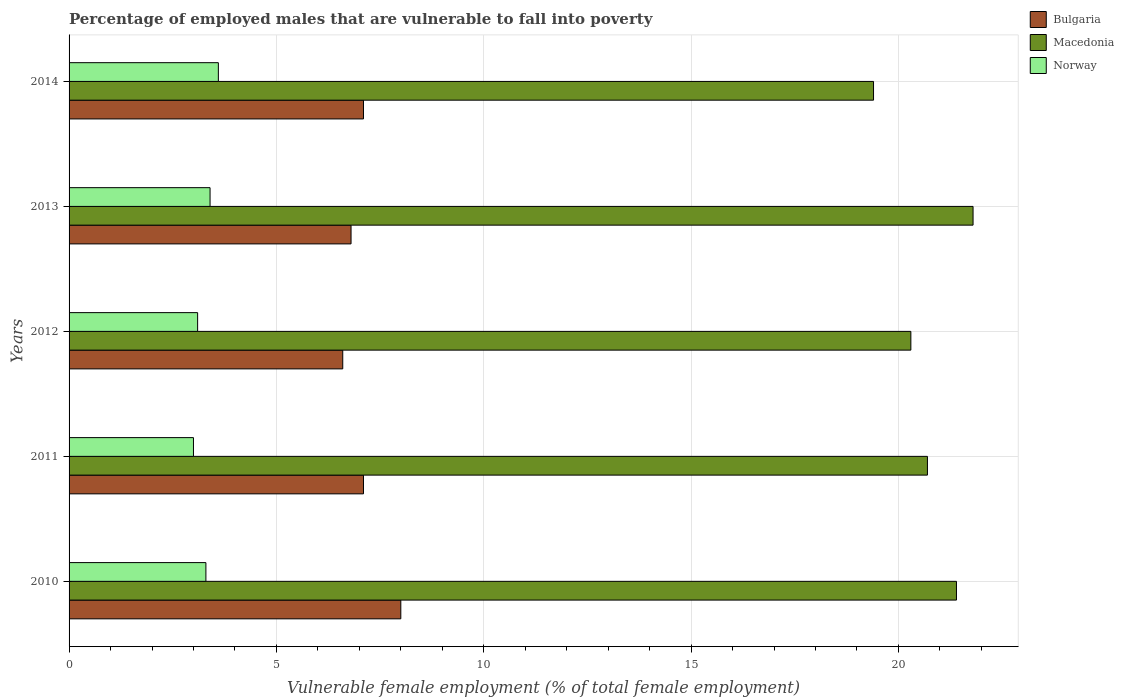How many different coloured bars are there?
Keep it short and to the point. 3. Are the number of bars on each tick of the Y-axis equal?
Give a very brief answer. Yes. How many bars are there on the 5th tick from the top?
Offer a very short reply. 3. How many bars are there on the 2nd tick from the bottom?
Provide a succinct answer. 3. What is the label of the 3rd group of bars from the top?
Make the answer very short. 2012. What is the percentage of employed males who are vulnerable to fall into poverty in Norway in 2010?
Provide a short and direct response. 3.3. Across all years, what is the minimum percentage of employed males who are vulnerable to fall into poverty in Norway?
Make the answer very short. 3. In which year was the percentage of employed males who are vulnerable to fall into poverty in Bulgaria maximum?
Make the answer very short. 2010. What is the total percentage of employed males who are vulnerable to fall into poverty in Norway in the graph?
Your answer should be compact. 16.4. What is the difference between the percentage of employed males who are vulnerable to fall into poverty in Macedonia in 2012 and that in 2014?
Provide a short and direct response. 0.9. What is the difference between the percentage of employed males who are vulnerable to fall into poverty in Macedonia in 2010 and the percentage of employed males who are vulnerable to fall into poverty in Norway in 2014?
Offer a terse response. 17.8. What is the average percentage of employed males who are vulnerable to fall into poverty in Macedonia per year?
Your answer should be compact. 20.72. In the year 2012, what is the difference between the percentage of employed males who are vulnerable to fall into poverty in Norway and percentage of employed males who are vulnerable to fall into poverty in Bulgaria?
Make the answer very short. -3.5. What is the ratio of the percentage of employed males who are vulnerable to fall into poverty in Bulgaria in 2013 to that in 2014?
Ensure brevity in your answer.  0.96. Is the percentage of employed males who are vulnerable to fall into poverty in Norway in 2013 less than that in 2014?
Offer a terse response. Yes. Is the difference between the percentage of employed males who are vulnerable to fall into poverty in Norway in 2010 and 2014 greater than the difference between the percentage of employed males who are vulnerable to fall into poverty in Bulgaria in 2010 and 2014?
Keep it short and to the point. No. What is the difference between the highest and the second highest percentage of employed males who are vulnerable to fall into poverty in Macedonia?
Offer a very short reply. 0.4. What is the difference between the highest and the lowest percentage of employed males who are vulnerable to fall into poverty in Bulgaria?
Provide a succinct answer. 1.4. Is it the case that in every year, the sum of the percentage of employed males who are vulnerable to fall into poverty in Macedonia and percentage of employed males who are vulnerable to fall into poverty in Bulgaria is greater than the percentage of employed males who are vulnerable to fall into poverty in Norway?
Make the answer very short. Yes. How many bars are there?
Offer a very short reply. 15. How many years are there in the graph?
Provide a short and direct response. 5. What is the difference between two consecutive major ticks on the X-axis?
Offer a terse response. 5. Are the values on the major ticks of X-axis written in scientific E-notation?
Your response must be concise. No. Does the graph contain any zero values?
Your answer should be compact. No. Where does the legend appear in the graph?
Provide a succinct answer. Top right. What is the title of the graph?
Provide a short and direct response. Percentage of employed males that are vulnerable to fall into poverty. What is the label or title of the X-axis?
Give a very brief answer. Vulnerable female employment (% of total female employment). What is the label or title of the Y-axis?
Make the answer very short. Years. What is the Vulnerable female employment (% of total female employment) in Bulgaria in 2010?
Ensure brevity in your answer.  8. What is the Vulnerable female employment (% of total female employment) of Macedonia in 2010?
Your response must be concise. 21.4. What is the Vulnerable female employment (% of total female employment) of Norway in 2010?
Provide a succinct answer. 3.3. What is the Vulnerable female employment (% of total female employment) of Bulgaria in 2011?
Ensure brevity in your answer.  7.1. What is the Vulnerable female employment (% of total female employment) in Macedonia in 2011?
Your response must be concise. 20.7. What is the Vulnerable female employment (% of total female employment) of Bulgaria in 2012?
Give a very brief answer. 6.6. What is the Vulnerable female employment (% of total female employment) of Macedonia in 2012?
Your response must be concise. 20.3. What is the Vulnerable female employment (% of total female employment) in Norway in 2012?
Your response must be concise. 3.1. What is the Vulnerable female employment (% of total female employment) of Bulgaria in 2013?
Offer a very short reply. 6.8. What is the Vulnerable female employment (% of total female employment) of Macedonia in 2013?
Ensure brevity in your answer.  21.8. What is the Vulnerable female employment (% of total female employment) of Norway in 2013?
Offer a very short reply. 3.4. What is the Vulnerable female employment (% of total female employment) in Bulgaria in 2014?
Your response must be concise. 7.1. What is the Vulnerable female employment (% of total female employment) of Macedonia in 2014?
Your answer should be compact. 19.4. What is the Vulnerable female employment (% of total female employment) of Norway in 2014?
Provide a succinct answer. 3.6. Across all years, what is the maximum Vulnerable female employment (% of total female employment) in Macedonia?
Offer a very short reply. 21.8. Across all years, what is the maximum Vulnerable female employment (% of total female employment) in Norway?
Provide a succinct answer. 3.6. Across all years, what is the minimum Vulnerable female employment (% of total female employment) in Bulgaria?
Your answer should be very brief. 6.6. Across all years, what is the minimum Vulnerable female employment (% of total female employment) of Macedonia?
Provide a succinct answer. 19.4. Across all years, what is the minimum Vulnerable female employment (% of total female employment) in Norway?
Provide a succinct answer. 3. What is the total Vulnerable female employment (% of total female employment) in Bulgaria in the graph?
Keep it short and to the point. 35.6. What is the total Vulnerable female employment (% of total female employment) in Macedonia in the graph?
Your answer should be very brief. 103.6. What is the difference between the Vulnerable female employment (% of total female employment) of Bulgaria in 2010 and that in 2011?
Your answer should be very brief. 0.9. What is the difference between the Vulnerable female employment (% of total female employment) of Norway in 2010 and that in 2012?
Give a very brief answer. 0.2. What is the difference between the Vulnerable female employment (% of total female employment) in Macedonia in 2010 and that in 2013?
Provide a short and direct response. -0.4. What is the difference between the Vulnerable female employment (% of total female employment) of Norway in 2010 and that in 2013?
Ensure brevity in your answer.  -0.1. What is the difference between the Vulnerable female employment (% of total female employment) in Bulgaria in 2010 and that in 2014?
Keep it short and to the point. 0.9. What is the difference between the Vulnerable female employment (% of total female employment) in Norway in 2010 and that in 2014?
Make the answer very short. -0.3. What is the difference between the Vulnerable female employment (% of total female employment) of Norway in 2011 and that in 2012?
Give a very brief answer. -0.1. What is the difference between the Vulnerable female employment (% of total female employment) in Macedonia in 2011 and that in 2013?
Ensure brevity in your answer.  -1.1. What is the difference between the Vulnerable female employment (% of total female employment) in Bulgaria in 2011 and that in 2014?
Ensure brevity in your answer.  0. What is the difference between the Vulnerable female employment (% of total female employment) of Macedonia in 2011 and that in 2014?
Provide a succinct answer. 1.3. What is the difference between the Vulnerable female employment (% of total female employment) of Norway in 2011 and that in 2014?
Make the answer very short. -0.6. What is the difference between the Vulnerable female employment (% of total female employment) of Macedonia in 2012 and that in 2013?
Give a very brief answer. -1.5. What is the difference between the Vulnerable female employment (% of total female employment) of Norway in 2012 and that in 2013?
Keep it short and to the point. -0.3. What is the difference between the Vulnerable female employment (% of total female employment) in Bulgaria in 2012 and that in 2014?
Provide a succinct answer. -0.5. What is the difference between the Vulnerable female employment (% of total female employment) in Norway in 2012 and that in 2014?
Your answer should be very brief. -0.5. What is the difference between the Vulnerable female employment (% of total female employment) of Macedonia in 2010 and the Vulnerable female employment (% of total female employment) of Norway in 2011?
Your answer should be compact. 18.4. What is the difference between the Vulnerable female employment (% of total female employment) in Bulgaria in 2010 and the Vulnerable female employment (% of total female employment) in Norway in 2012?
Make the answer very short. 4.9. What is the difference between the Vulnerable female employment (% of total female employment) of Macedonia in 2010 and the Vulnerable female employment (% of total female employment) of Norway in 2012?
Give a very brief answer. 18.3. What is the difference between the Vulnerable female employment (% of total female employment) of Bulgaria in 2010 and the Vulnerable female employment (% of total female employment) of Macedonia in 2013?
Make the answer very short. -13.8. What is the difference between the Vulnerable female employment (% of total female employment) in Bulgaria in 2010 and the Vulnerable female employment (% of total female employment) in Macedonia in 2014?
Keep it short and to the point. -11.4. What is the difference between the Vulnerable female employment (% of total female employment) in Bulgaria in 2010 and the Vulnerable female employment (% of total female employment) in Norway in 2014?
Offer a very short reply. 4.4. What is the difference between the Vulnerable female employment (% of total female employment) of Bulgaria in 2011 and the Vulnerable female employment (% of total female employment) of Macedonia in 2012?
Provide a short and direct response. -13.2. What is the difference between the Vulnerable female employment (% of total female employment) of Bulgaria in 2011 and the Vulnerable female employment (% of total female employment) of Norway in 2012?
Give a very brief answer. 4. What is the difference between the Vulnerable female employment (% of total female employment) of Bulgaria in 2011 and the Vulnerable female employment (% of total female employment) of Macedonia in 2013?
Offer a very short reply. -14.7. What is the difference between the Vulnerable female employment (% of total female employment) in Bulgaria in 2011 and the Vulnerable female employment (% of total female employment) in Norway in 2013?
Provide a succinct answer. 3.7. What is the difference between the Vulnerable female employment (% of total female employment) in Macedonia in 2011 and the Vulnerable female employment (% of total female employment) in Norway in 2013?
Make the answer very short. 17.3. What is the difference between the Vulnerable female employment (% of total female employment) in Bulgaria in 2012 and the Vulnerable female employment (% of total female employment) in Macedonia in 2013?
Offer a very short reply. -15.2. What is the difference between the Vulnerable female employment (% of total female employment) in Macedonia in 2012 and the Vulnerable female employment (% of total female employment) in Norway in 2013?
Offer a terse response. 16.9. What is the difference between the Vulnerable female employment (% of total female employment) in Bulgaria in 2012 and the Vulnerable female employment (% of total female employment) in Macedonia in 2014?
Make the answer very short. -12.8. What is the difference between the Vulnerable female employment (% of total female employment) in Bulgaria in 2012 and the Vulnerable female employment (% of total female employment) in Norway in 2014?
Your answer should be compact. 3. What is the difference between the Vulnerable female employment (% of total female employment) in Macedonia in 2012 and the Vulnerable female employment (% of total female employment) in Norway in 2014?
Your response must be concise. 16.7. What is the difference between the Vulnerable female employment (% of total female employment) of Macedonia in 2013 and the Vulnerable female employment (% of total female employment) of Norway in 2014?
Provide a succinct answer. 18.2. What is the average Vulnerable female employment (% of total female employment) in Bulgaria per year?
Give a very brief answer. 7.12. What is the average Vulnerable female employment (% of total female employment) in Macedonia per year?
Offer a very short reply. 20.72. What is the average Vulnerable female employment (% of total female employment) in Norway per year?
Offer a very short reply. 3.28. In the year 2010, what is the difference between the Vulnerable female employment (% of total female employment) in Bulgaria and Vulnerable female employment (% of total female employment) in Macedonia?
Make the answer very short. -13.4. In the year 2010, what is the difference between the Vulnerable female employment (% of total female employment) in Macedonia and Vulnerable female employment (% of total female employment) in Norway?
Keep it short and to the point. 18.1. In the year 2011, what is the difference between the Vulnerable female employment (% of total female employment) in Bulgaria and Vulnerable female employment (% of total female employment) in Macedonia?
Give a very brief answer. -13.6. In the year 2012, what is the difference between the Vulnerable female employment (% of total female employment) in Bulgaria and Vulnerable female employment (% of total female employment) in Macedonia?
Make the answer very short. -13.7. In the year 2012, what is the difference between the Vulnerable female employment (% of total female employment) in Macedonia and Vulnerable female employment (% of total female employment) in Norway?
Your answer should be very brief. 17.2. In the year 2013, what is the difference between the Vulnerable female employment (% of total female employment) in Bulgaria and Vulnerable female employment (% of total female employment) in Macedonia?
Make the answer very short. -15. In the year 2013, what is the difference between the Vulnerable female employment (% of total female employment) of Bulgaria and Vulnerable female employment (% of total female employment) of Norway?
Offer a terse response. 3.4. In the year 2013, what is the difference between the Vulnerable female employment (% of total female employment) in Macedonia and Vulnerable female employment (% of total female employment) in Norway?
Offer a very short reply. 18.4. In the year 2014, what is the difference between the Vulnerable female employment (% of total female employment) of Bulgaria and Vulnerable female employment (% of total female employment) of Macedonia?
Make the answer very short. -12.3. In the year 2014, what is the difference between the Vulnerable female employment (% of total female employment) in Bulgaria and Vulnerable female employment (% of total female employment) in Norway?
Ensure brevity in your answer.  3.5. In the year 2014, what is the difference between the Vulnerable female employment (% of total female employment) in Macedonia and Vulnerable female employment (% of total female employment) in Norway?
Make the answer very short. 15.8. What is the ratio of the Vulnerable female employment (% of total female employment) of Bulgaria in 2010 to that in 2011?
Make the answer very short. 1.13. What is the ratio of the Vulnerable female employment (% of total female employment) in Macedonia in 2010 to that in 2011?
Your answer should be very brief. 1.03. What is the ratio of the Vulnerable female employment (% of total female employment) in Bulgaria in 2010 to that in 2012?
Your response must be concise. 1.21. What is the ratio of the Vulnerable female employment (% of total female employment) in Macedonia in 2010 to that in 2012?
Make the answer very short. 1.05. What is the ratio of the Vulnerable female employment (% of total female employment) in Norway in 2010 to that in 2012?
Give a very brief answer. 1.06. What is the ratio of the Vulnerable female employment (% of total female employment) in Bulgaria in 2010 to that in 2013?
Ensure brevity in your answer.  1.18. What is the ratio of the Vulnerable female employment (% of total female employment) in Macedonia in 2010 to that in 2013?
Ensure brevity in your answer.  0.98. What is the ratio of the Vulnerable female employment (% of total female employment) in Norway in 2010 to that in 2013?
Offer a very short reply. 0.97. What is the ratio of the Vulnerable female employment (% of total female employment) of Bulgaria in 2010 to that in 2014?
Your answer should be very brief. 1.13. What is the ratio of the Vulnerable female employment (% of total female employment) in Macedonia in 2010 to that in 2014?
Provide a short and direct response. 1.1. What is the ratio of the Vulnerable female employment (% of total female employment) of Bulgaria in 2011 to that in 2012?
Make the answer very short. 1.08. What is the ratio of the Vulnerable female employment (% of total female employment) in Macedonia in 2011 to that in 2012?
Offer a very short reply. 1.02. What is the ratio of the Vulnerable female employment (% of total female employment) of Bulgaria in 2011 to that in 2013?
Keep it short and to the point. 1.04. What is the ratio of the Vulnerable female employment (% of total female employment) in Macedonia in 2011 to that in 2013?
Give a very brief answer. 0.95. What is the ratio of the Vulnerable female employment (% of total female employment) in Norway in 2011 to that in 2013?
Make the answer very short. 0.88. What is the ratio of the Vulnerable female employment (% of total female employment) in Bulgaria in 2011 to that in 2014?
Offer a very short reply. 1. What is the ratio of the Vulnerable female employment (% of total female employment) in Macedonia in 2011 to that in 2014?
Keep it short and to the point. 1.07. What is the ratio of the Vulnerable female employment (% of total female employment) of Bulgaria in 2012 to that in 2013?
Provide a short and direct response. 0.97. What is the ratio of the Vulnerable female employment (% of total female employment) of Macedonia in 2012 to that in 2013?
Make the answer very short. 0.93. What is the ratio of the Vulnerable female employment (% of total female employment) of Norway in 2012 to that in 2013?
Your answer should be very brief. 0.91. What is the ratio of the Vulnerable female employment (% of total female employment) in Bulgaria in 2012 to that in 2014?
Ensure brevity in your answer.  0.93. What is the ratio of the Vulnerable female employment (% of total female employment) of Macedonia in 2012 to that in 2014?
Provide a succinct answer. 1.05. What is the ratio of the Vulnerable female employment (% of total female employment) in Norway in 2012 to that in 2014?
Provide a succinct answer. 0.86. What is the ratio of the Vulnerable female employment (% of total female employment) in Bulgaria in 2013 to that in 2014?
Your response must be concise. 0.96. What is the ratio of the Vulnerable female employment (% of total female employment) of Macedonia in 2013 to that in 2014?
Your answer should be very brief. 1.12. What is the difference between the highest and the second highest Vulnerable female employment (% of total female employment) of Macedonia?
Your answer should be very brief. 0.4. What is the difference between the highest and the second highest Vulnerable female employment (% of total female employment) of Norway?
Your answer should be compact. 0.2. 